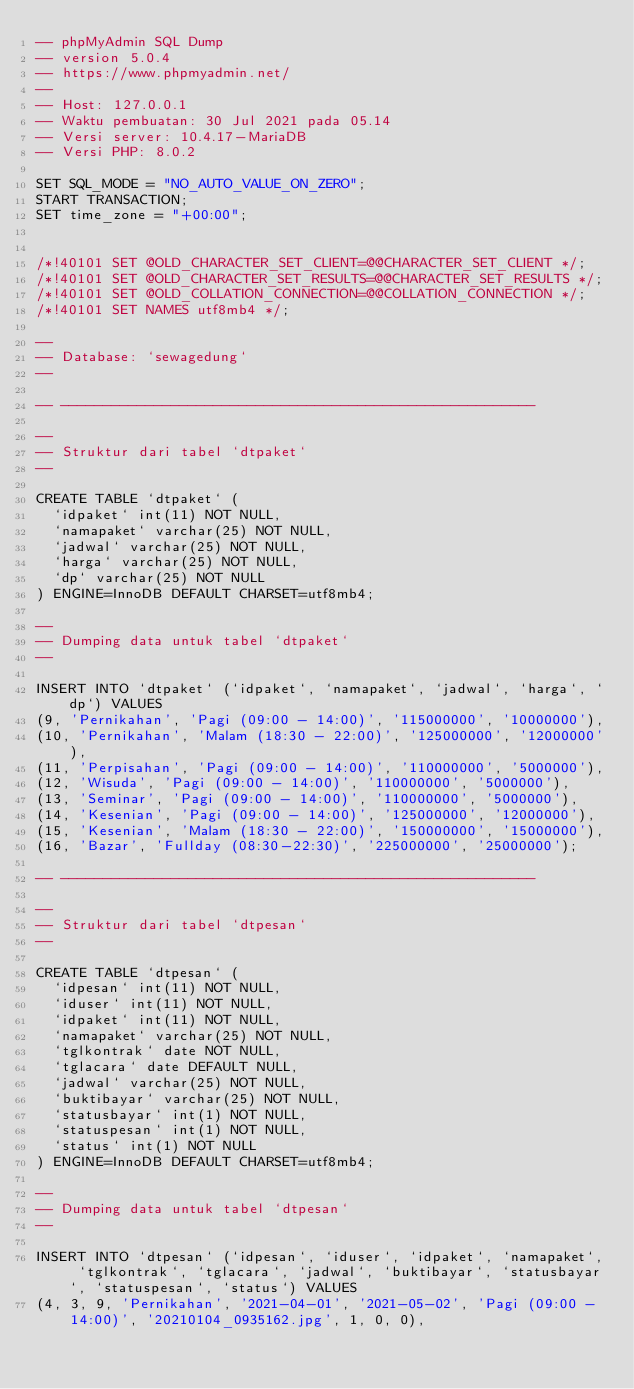<code> <loc_0><loc_0><loc_500><loc_500><_SQL_>-- phpMyAdmin SQL Dump
-- version 5.0.4
-- https://www.phpmyadmin.net/
--
-- Host: 127.0.0.1
-- Waktu pembuatan: 30 Jul 2021 pada 05.14
-- Versi server: 10.4.17-MariaDB
-- Versi PHP: 8.0.2

SET SQL_MODE = "NO_AUTO_VALUE_ON_ZERO";
START TRANSACTION;
SET time_zone = "+00:00";


/*!40101 SET @OLD_CHARACTER_SET_CLIENT=@@CHARACTER_SET_CLIENT */;
/*!40101 SET @OLD_CHARACTER_SET_RESULTS=@@CHARACTER_SET_RESULTS */;
/*!40101 SET @OLD_COLLATION_CONNECTION=@@COLLATION_CONNECTION */;
/*!40101 SET NAMES utf8mb4 */;

--
-- Database: `sewagedung`
--

-- --------------------------------------------------------

--
-- Struktur dari tabel `dtpaket`
--

CREATE TABLE `dtpaket` (
  `idpaket` int(11) NOT NULL,
  `namapaket` varchar(25) NOT NULL,
  `jadwal` varchar(25) NOT NULL,
  `harga` varchar(25) NOT NULL,
  `dp` varchar(25) NOT NULL
) ENGINE=InnoDB DEFAULT CHARSET=utf8mb4;

--
-- Dumping data untuk tabel `dtpaket`
--

INSERT INTO `dtpaket` (`idpaket`, `namapaket`, `jadwal`, `harga`, `dp`) VALUES
(9, 'Pernikahan', 'Pagi (09:00 - 14:00)', '115000000', '10000000'),
(10, 'Pernikahan', 'Malam (18:30 - 22:00)', '125000000', '12000000'),
(11, 'Perpisahan', 'Pagi (09:00 - 14:00)', '110000000', '5000000'),
(12, 'Wisuda', 'Pagi (09:00 - 14:00)', '110000000', '5000000'),
(13, 'Seminar', 'Pagi (09:00 - 14:00)', '110000000', '5000000'),
(14, 'Kesenian', 'Pagi (09:00 - 14:00)', '125000000', '12000000'),
(15, 'Kesenian', 'Malam (18:30 - 22:00)', '150000000', '15000000'),
(16, 'Bazar', 'Fullday (08:30-22:30)', '225000000', '25000000');

-- --------------------------------------------------------

--
-- Struktur dari tabel `dtpesan`
--

CREATE TABLE `dtpesan` (
  `idpesan` int(11) NOT NULL,
  `iduser` int(11) NOT NULL,
  `idpaket` int(11) NOT NULL,
  `namapaket` varchar(25) NOT NULL,
  `tglkontrak` date NOT NULL,
  `tglacara` date DEFAULT NULL,
  `jadwal` varchar(25) NOT NULL,
  `buktibayar` varchar(25) NOT NULL,
  `statusbayar` int(1) NOT NULL,
  `statuspesan` int(1) NOT NULL,
  `status` int(1) NOT NULL
) ENGINE=InnoDB DEFAULT CHARSET=utf8mb4;

--
-- Dumping data untuk tabel `dtpesan`
--

INSERT INTO `dtpesan` (`idpesan`, `iduser`, `idpaket`, `namapaket`, `tglkontrak`, `tglacara`, `jadwal`, `buktibayar`, `statusbayar`, `statuspesan`, `status`) VALUES
(4, 3, 9, 'Pernikahan', '2021-04-01', '2021-05-02', 'Pagi (09:00 - 14:00)', '20210104_0935162.jpg', 1, 0, 0),</code> 